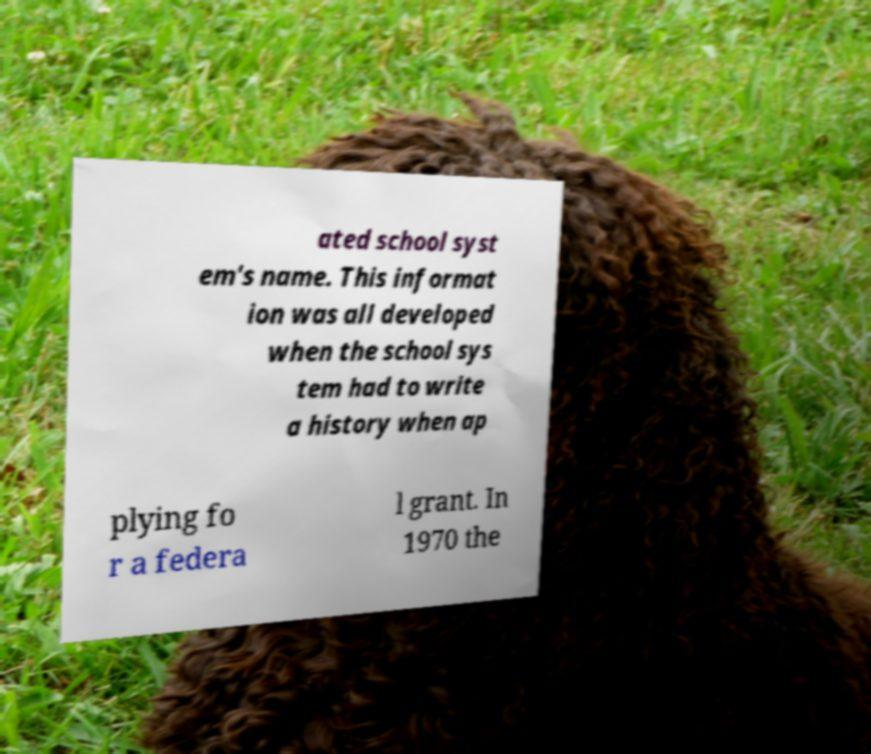I need the written content from this picture converted into text. Can you do that? ated school syst em's name. This informat ion was all developed when the school sys tem had to write a history when ap plying fo r a federa l grant. In 1970 the 